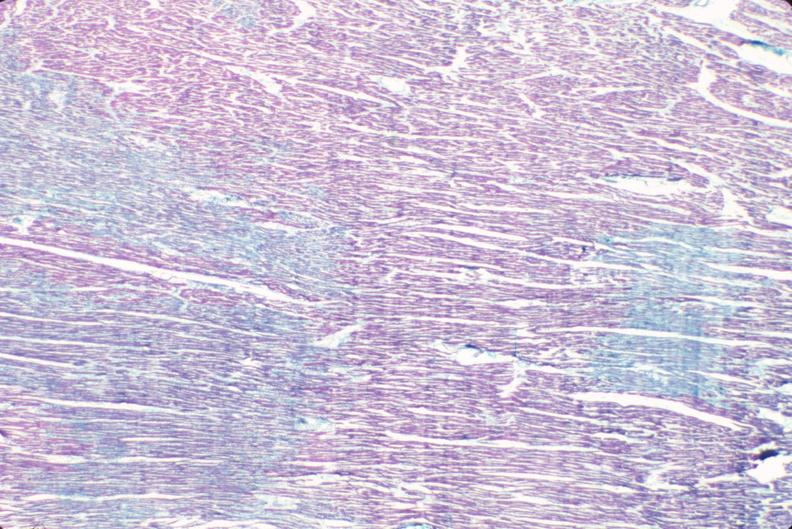s peritoneal fluid present?
Answer the question using a single word or phrase. No 